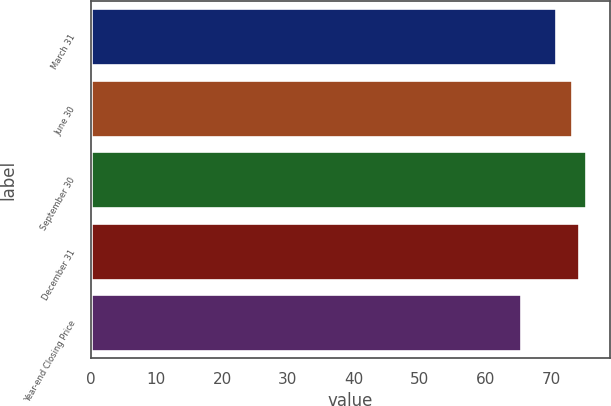Convert chart to OTSL. <chart><loc_0><loc_0><loc_500><loc_500><bar_chart><fcel>March 31<fcel>June 30<fcel>September 30<fcel>December 31<fcel>Year-end Closing Price<nl><fcel>70.72<fcel>73.2<fcel>75.27<fcel>74.18<fcel>65.44<nl></chart> 